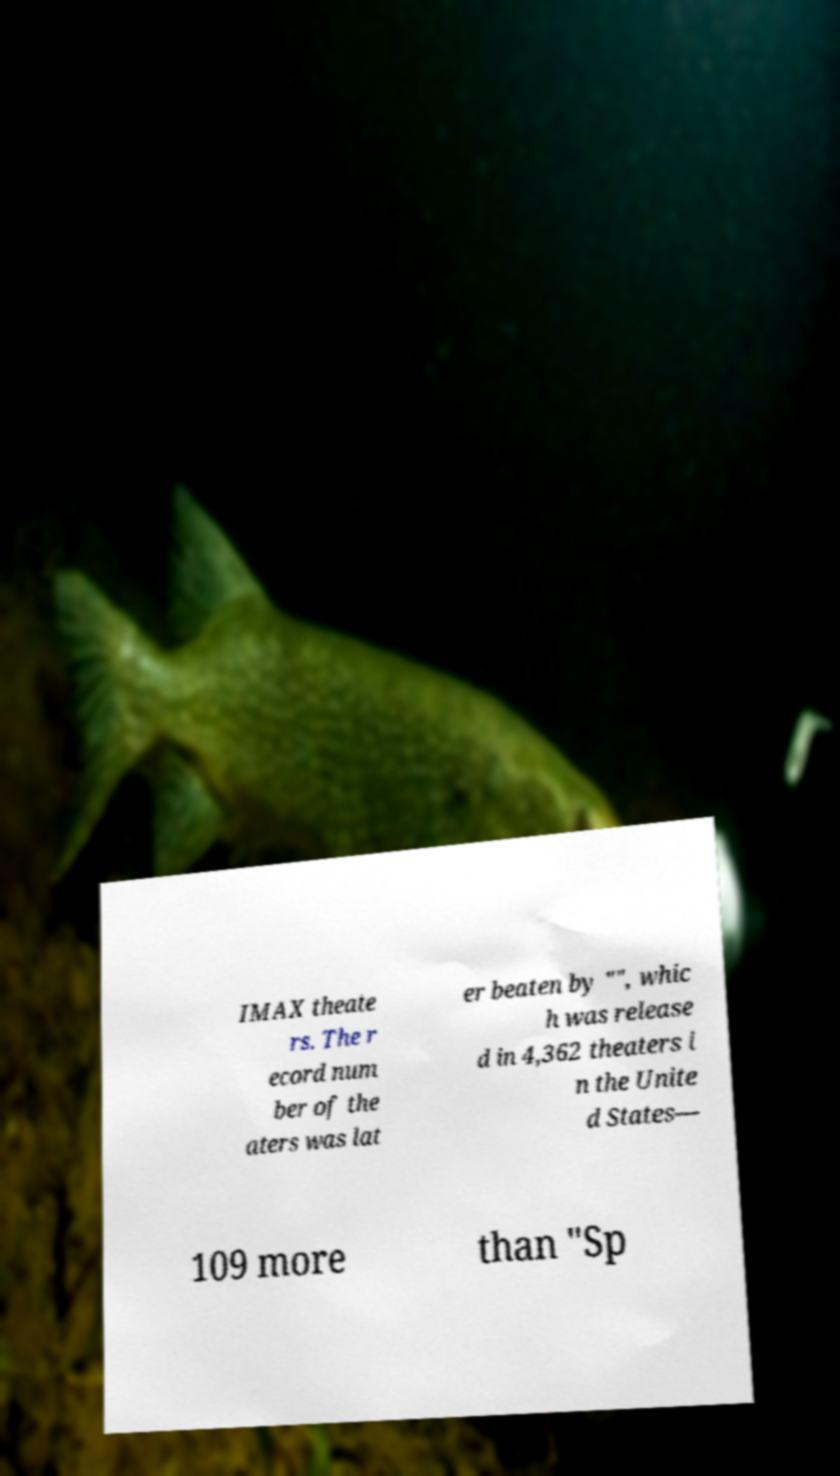Can you accurately transcribe the text from the provided image for me? IMAX theate rs. The r ecord num ber of the aters was lat er beaten by "", whic h was release d in 4,362 theaters i n the Unite d States— 109 more than "Sp 